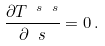<formula> <loc_0><loc_0><loc_500><loc_500>\frac { \partial T ^ { \ s \ s } } { \partial \ s } = 0 \, .</formula> 